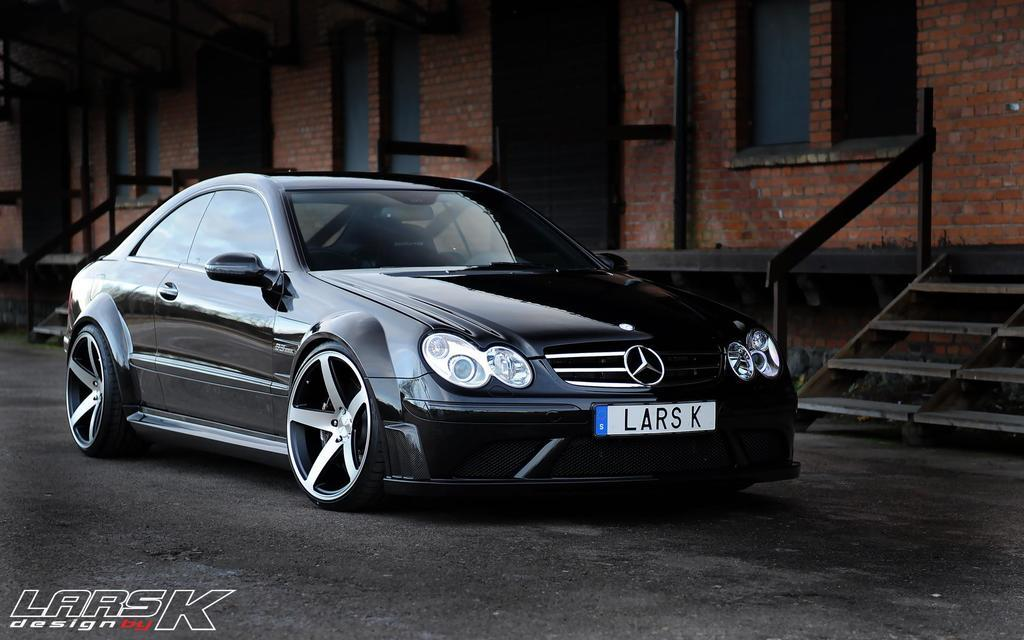What is the main subject of the image? There is a vehicle on the road in the image. What can be seen in the background of the image? There is a building in the background of the image. Is there any additional information about the image itself? Yes, there is a watermark on the image. What type of knife can be seen in the image? There is no knife present in the image; it features a vehicle on the road and a building in the background. 